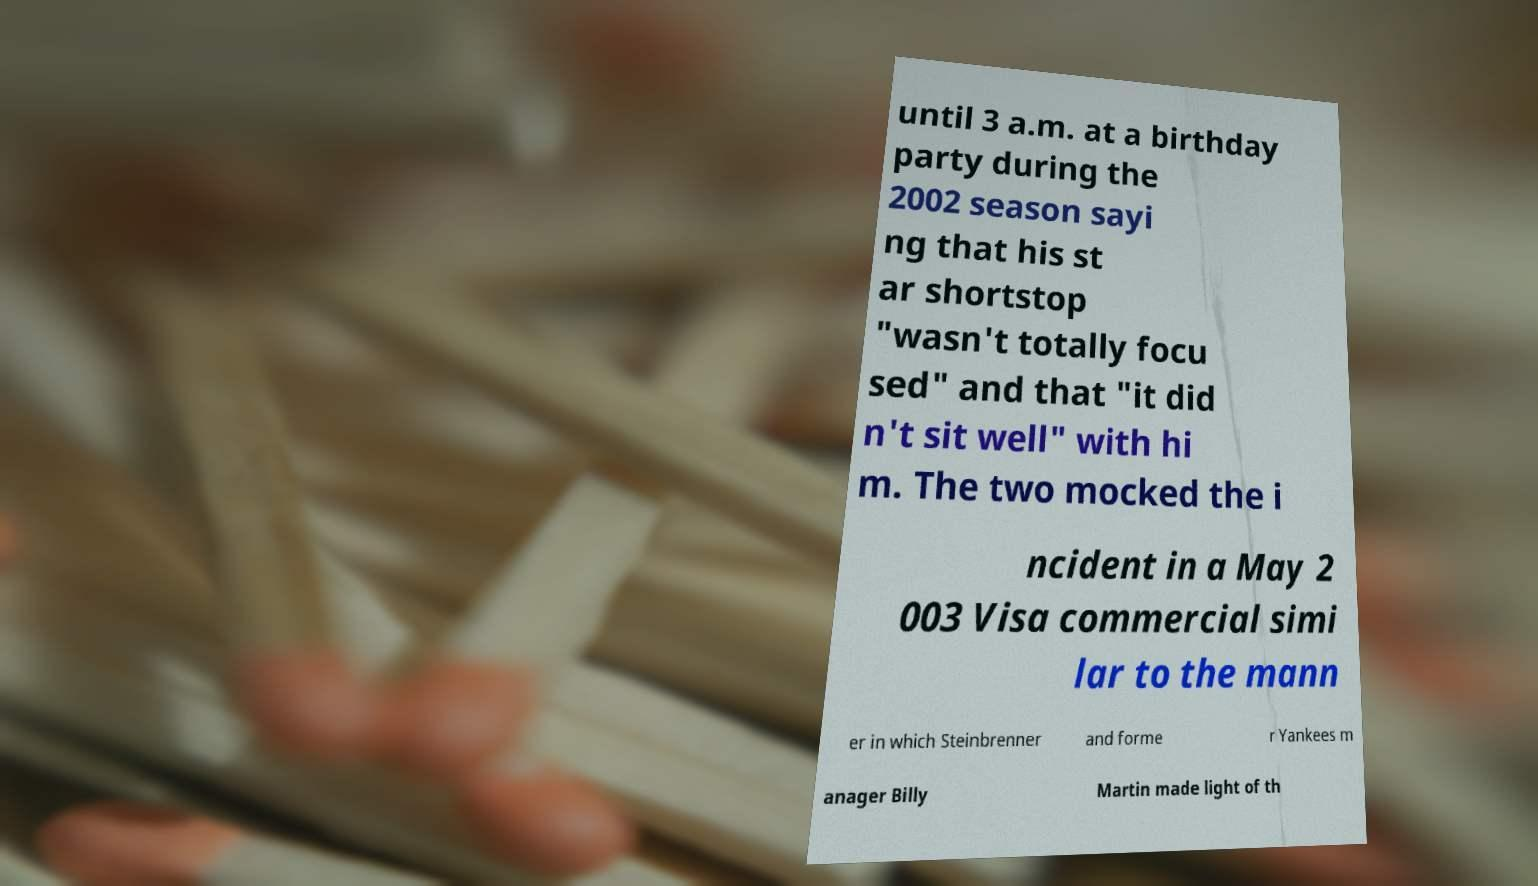Can you accurately transcribe the text from the provided image for me? until 3 a.m. at a birthday party during the 2002 season sayi ng that his st ar shortstop "wasn't totally focu sed" and that "it did n't sit well" with hi m. The two mocked the i ncident in a May 2 003 Visa commercial simi lar to the mann er in which Steinbrenner and forme r Yankees m anager Billy Martin made light of th 